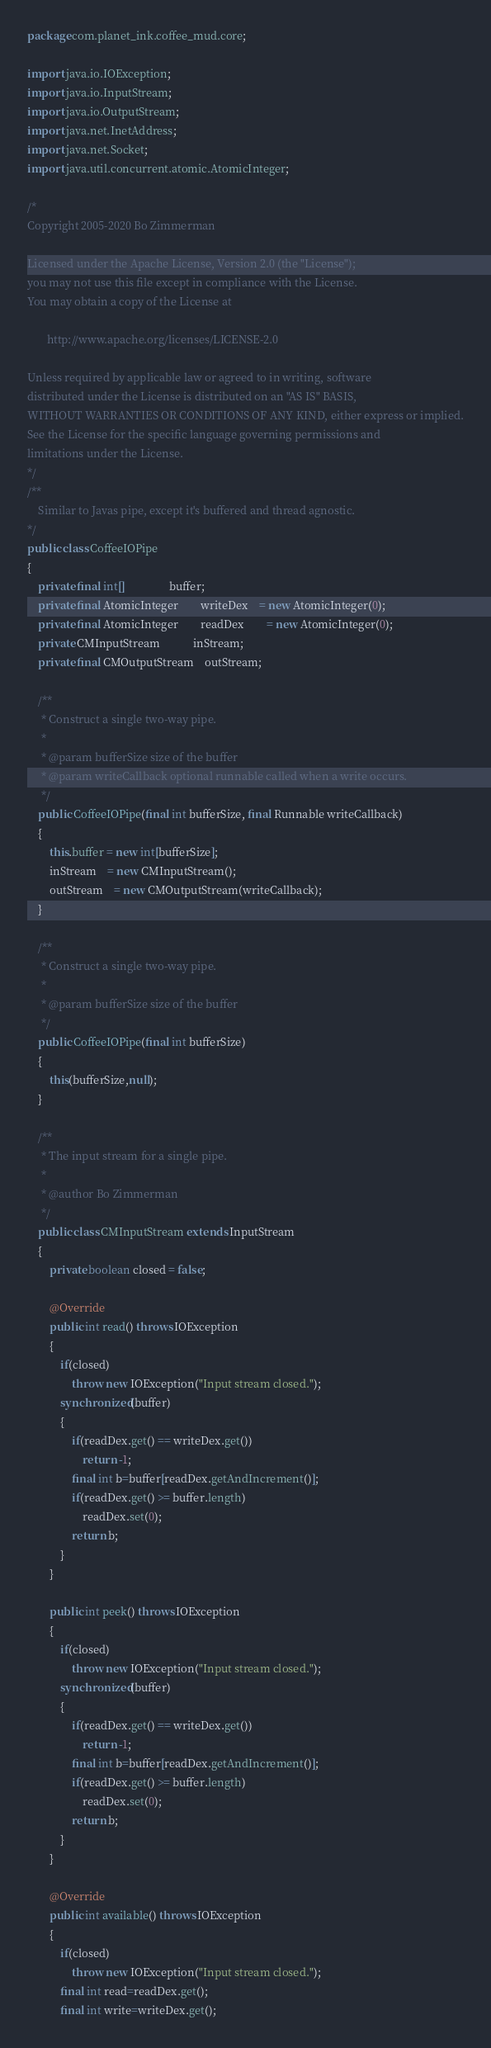Convert code to text. <code><loc_0><loc_0><loc_500><loc_500><_Java_>package com.planet_ink.coffee_mud.core;

import java.io.IOException;
import java.io.InputStream;
import java.io.OutputStream;
import java.net.InetAddress;
import java.net.Socket;
import java.util.concurrent.atomic.AtomicInteger;

/*
Copyright 2005-2020 Bo Zimmerman

Licensed under the Apache License, Version 2.0 (the "License");
you may not use this file except in compliance with the License.
You may obtain a copy of the License at

	   http://www.apache.org/licenses/LICENSE-2.0

Unless required by applicable law or agreed to in writing, software
distributed under the License is distributed on an "AS IS" BASIS,
WITHOUT WARRANTIES OR CONDITIONS OF ANY KIND, either express or implied.
See the License for the specific language governing permissions and
limitations under the License.
*/
/**
	Similar to Javas pipe, except it's buffered and thread agnostic.
*/
public class CoffeeIOPipe
{
	private final int[]				buffer;
	private final AtomicInteger		writeDex	= new AtomicInteger(0);
	private final AtomicInteger		readDex		= new AtomicInteger(0);
	private CMInputStream			inStream;
	private final CMOutputStream	outStream;

	/**
	 * Construct a single two-way pipe.
	 *
	 * @param bufferSize size of the buffer
	 * @param writeCallback optional runnable called when a write occurs.
	 */
	public CoffeeIOPipe(final int bufferSize, final Runnable writeCallback)
	{
		this.buffer = new int[bufferSize];
		inStream	= new CMInputStream();
		outStream	= new CMOutputStream(writeCallback);
	}

	/**
	 * Construct a single two-way pipe.
	 *
	 * @param bufferSize size of the buffer
	 */
	public CoffeeIOPipe(final int bufferSize)
	{
		this(bufferSize,null);
	}

	/**
	 * The input stream for a single pipe.
	 *
	 * @author Bo Zimmerman
	 */
	public class CMInputStream extends InputStream
	{
		private boolean closed = false;

		@Override
		public int read() throws IOException
		{
			if(closed)
				throw new IOException("Input stream closed.");
			synchronized(buffer)
			{
				if(readDex.get() == writeDex.get())
					return -1;
				final int b=buffer[readDex.getAndIncrement()];
				if(readDex.get() >= buffer.length)
					readDex.set(0);
				return b;
			}
		}

		public int peek() throws IOException
		{
			if(closed)
				throw new IOException("Input stream closed.");
			synchronized(buffer)
			{
				if(readDex.get() == writeDex.get())
					return -1;
				final int b=buffer[readDex.getAndIncrement()];
				if(readDex.get() >= buffer.length)
					readDex.set(0);
				return b;
			}
		}

		@Override
		public int available() throws IOException
		{
			if(closed)
				throw new IOException("Input stream closed.");
			final int read=readDex.get();
			final int write=writeDex.get();</code> 